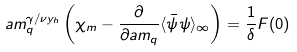<formula> <loc_0><loc_0><loc_500><loc_500>a m _ { q } ^ { \gamma / \nu y _ { h } } \left ( \chi _ { m } - \frac { \partial } { \partial a m _ { q } } \langle \bar { \psi } \psi \rangle _ { \infty } \right ) = \frac { 1 } { \delta } F ( 0 )</formula> 